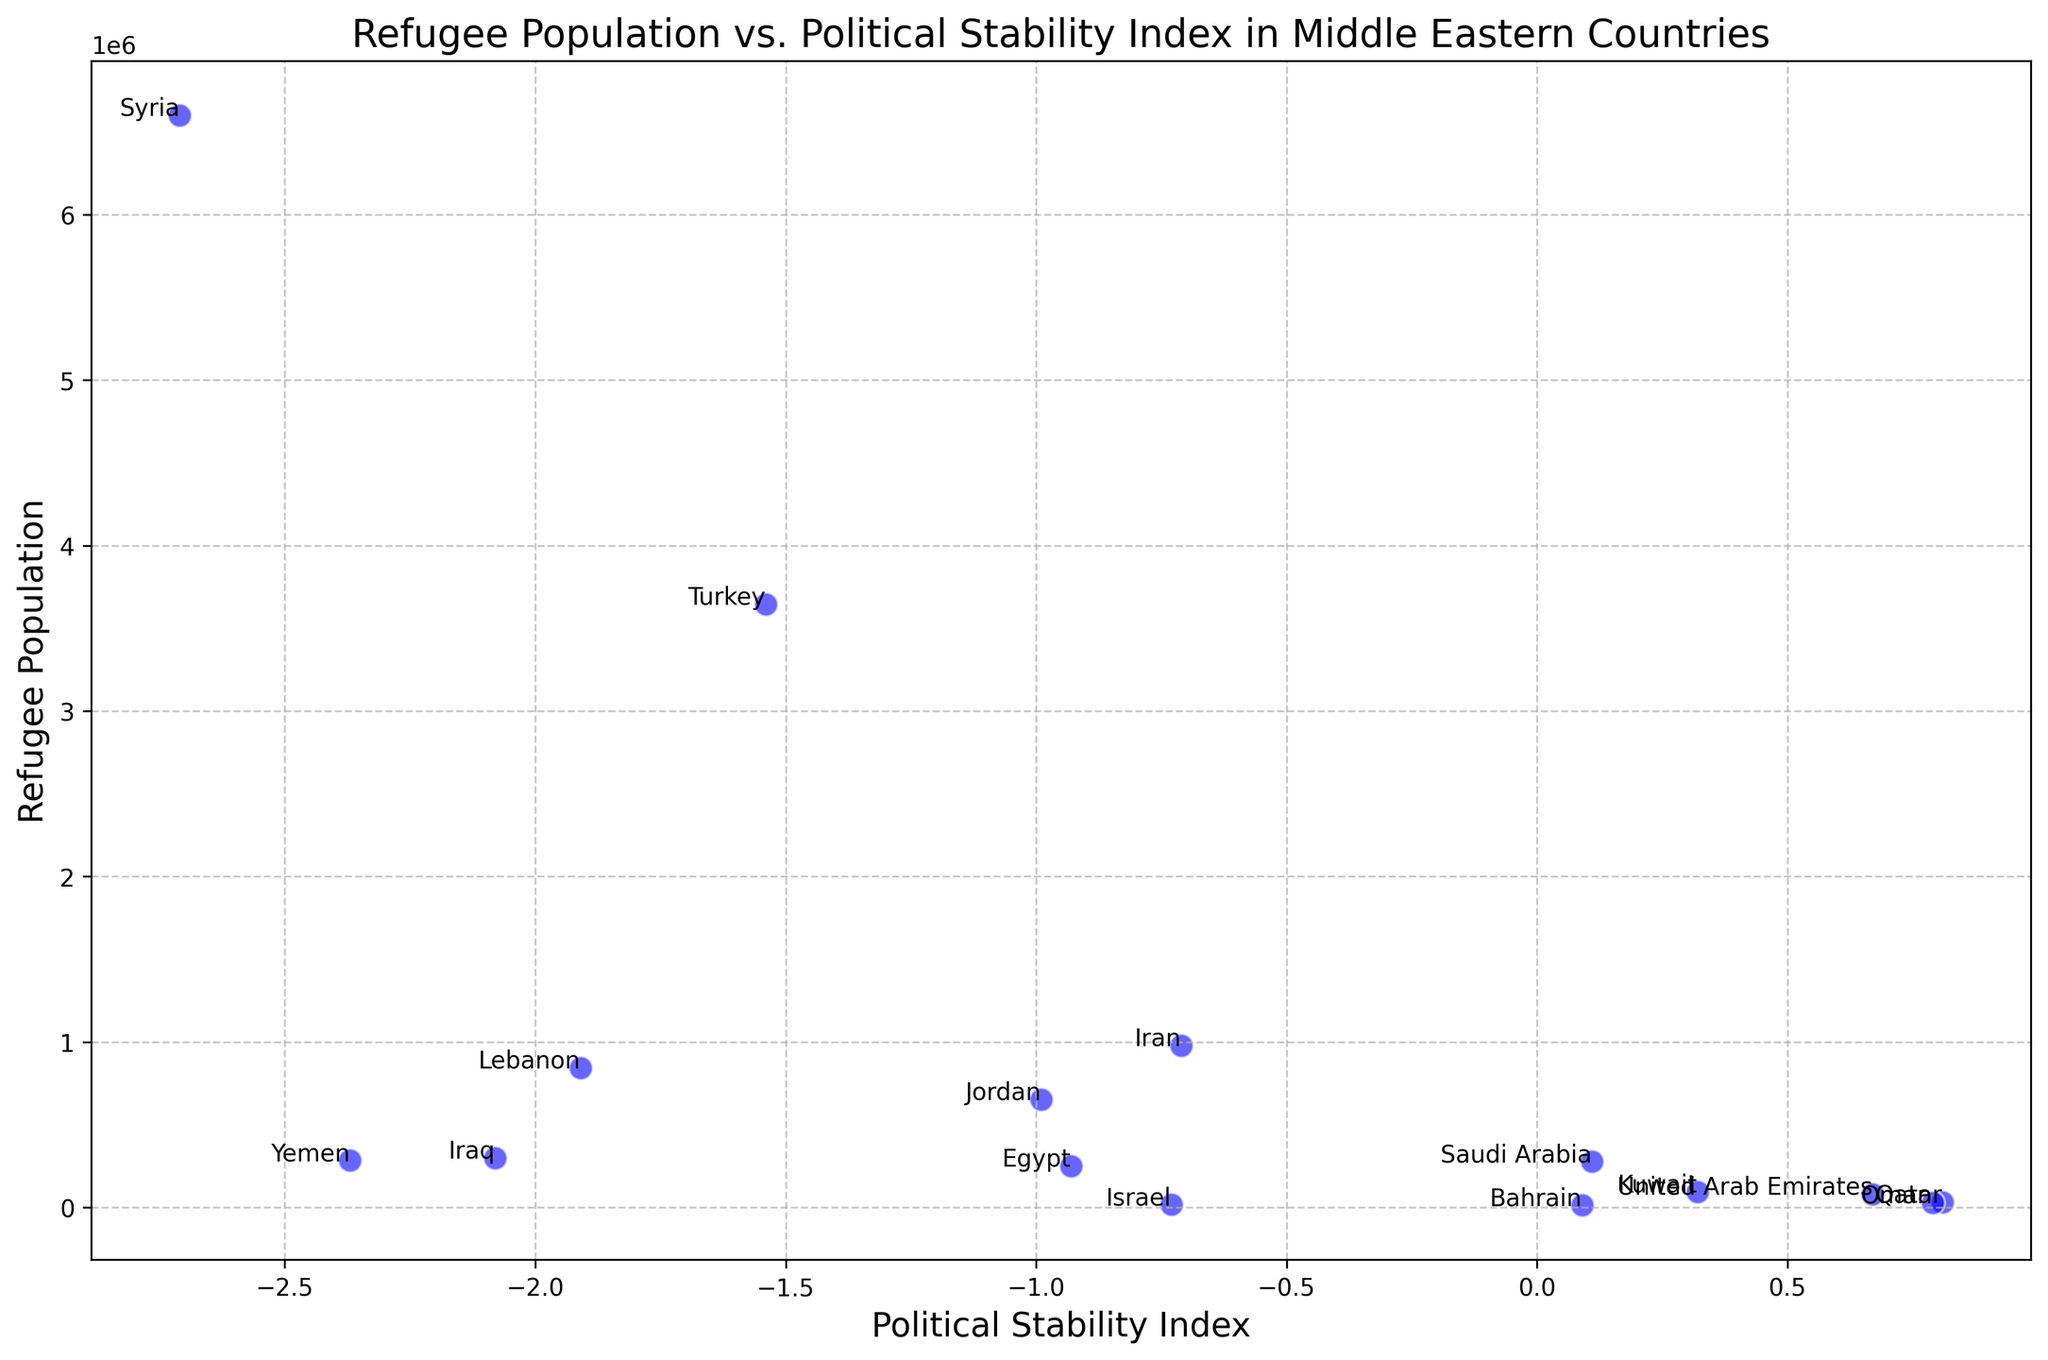Which country has the highest refugee population? By looking at the scatter plot, you can see that Syria has the highest refugee population compared to other countries in the plot.
Answer: Syria Which country has the lowest political stability index? In the scatter plot, the country with the lowest political stability index is Syria, as it has the lowest value on the Political Stability Index axis.
Answer: Syria Which countries have a positive political stability index? The countries with political stability indices greater than 0 in the scatter plot are Saudi Arabia, Kuwait, Qatar, Oman, United Arab Emirates, and Bahrain.
Answer: Saudi Arabia, Kuwait, Qatar, Oman, United Arab Emirates, Bahrain What's the total refugee population of Turkey and Lebanon combined? From the scatter plot, Turkey has a refugee population of 3,646,000 and Lebanon has 845,000. Summing these two values gives 3,646,000 + 845,000 = 4,491,000.
Answer: 4,491,000 How does the refugee population of Iran compare to that of Iraq? By examining the scatter plot, Iran has a refugee population of 979,400 while Iraq has 300,000. Therefore, Iran has a higher refugee population than Iraq.
Answer: Iran What is the average political stability index of Jordan, Egypt, and Israel? Jordan has an index of -0.99, Egypt -0.93, and Israel -0.73. Adding these values gives -0.99 + (-0.93) + (-0.73) = -2.65. Dividing by 3 gives an average of -2.65/3 = -0.883.
Answer: -0.883 Which country has a higher political stability index: Qatar or the United Arab Emirates? By looking at the scatter plot, Qatar has a political stability index of 0.81, and the United Arab Emirates has 0.67. Thus, Qatar has a higher political stability index.
Answer: Qatar What's the difference in refugee populations between Yemen and Kuwait? According to the scatter plot, Yemen has a refugee population of 284,000 and Kuwait has 95,000. The difference is 284,000 - 95,000 = 189,000.
Answer: 189,000 What's the median political stability index of the countries with a refugee population below 100,000? The countries listed on the scatter plot with refugee populations below 100,000 are Israel, Qatar, Oman, United Arab Emirates, Bahrain. Their political stability indices are -0.73, 0.81, 0.79, 0.67, and 0.09. Arranging these values in ascending order: -0.73, 0.09, 0.67, 0.79, 0.81. The median value is the middle one, which is 0.67.
Answer: 0.67 